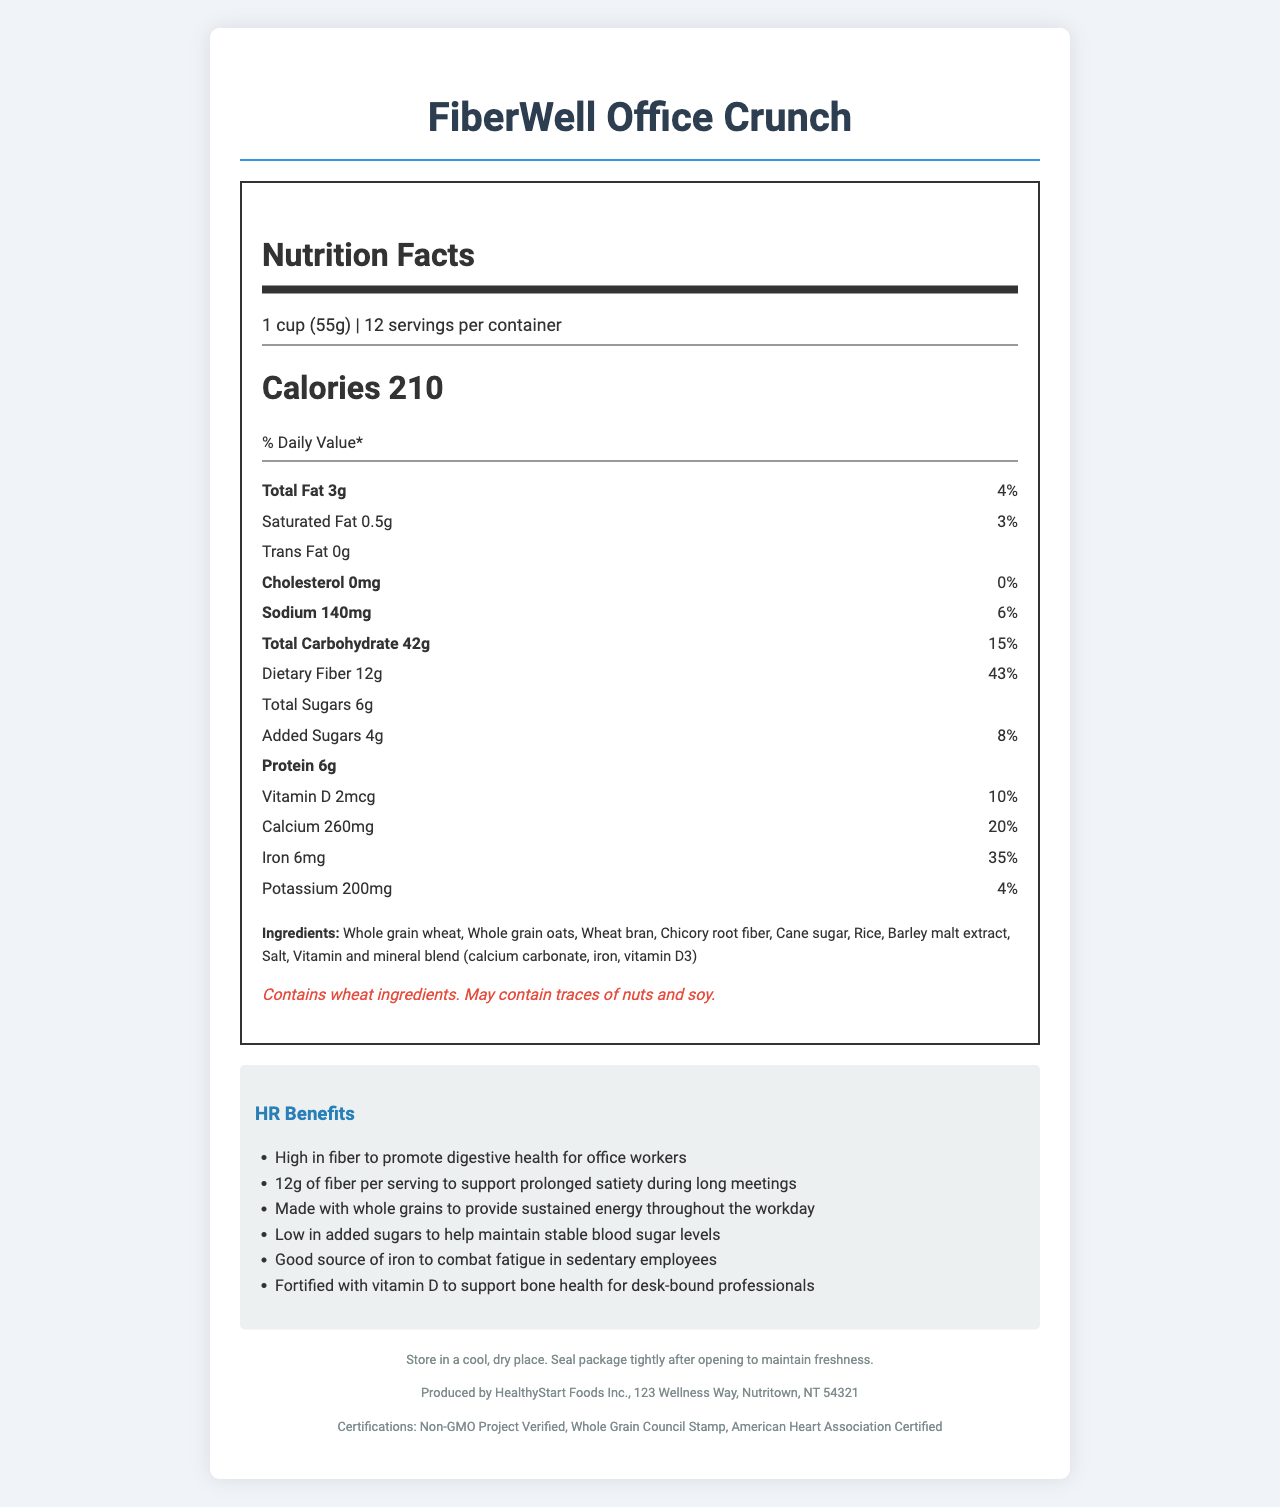what is the serving size of FiberWell Office Crunch? The serving size is provided in the document as "1 cup (55g)".
Answer: 1 cup (55g) how many servings are contained in one package? The document specifies that there are 12 servings per container.
Answer: 12 servings how many calories are in one serving of FiberWell Office Crunch? The calories per serving are labeled as 210.
Answer: 210 calories what is the percentage daily value of dietary fiber per serving? The daily value percentage of dietary fiber is indicated as 43%.
Answer: 43% which ingredient helps promote digestive health in office workers? Chicory root fiber is known for promoting digestive health and is listed as one of the ingredients.
Answer: Chicory root fiber what are the main sources of carbohydrates in FiberWell Office Crunch? A. Whole grain wheat and oats B. Cane sugar C. Chicory root fiber D. All of the above The main sources of carbohydrates are whole grain wheat and oats, as listed in the ingredient section.
Answer: A which nutrient is most likely targeted for combating fatigue among sedentary employees? A. Calcium B. Vitamin D C. Iron D. Sodium The claims for HR include "Good source of iron to combat fatigue in sedentary employees," making iron the correct answer.
Answer: C does FiberWell Office Crunch contain any trans fat? The document specifies that there are 0g of trans fat in the product.
Answer: No is FiberWell Office Crunch certified by the American Heart Association? The list of certifications includes "American Heart Association Certified."
Answer: Yes summarize the main health benefits promoted by FiberWell Office Crunch for office workers. The main health benefits include promoting digestive health with its high fiber content, providing sustained energy from whole grains, maintaining stable blood sugar due to its low added sugars, combating fatigue with a good source of iron, and supporting bone health with added vitamin D.
Answer: High in fiber for digestive health and prolonged satiety, provides sustained energy with whole grains, low in added sugars for stable blood sugar, good source of iron to combat fatigue, and fortified with vitamin D for bone health. how does the product help maintain stable blood sugar levels? The document mentions that the product is low in added sugars, which helps maintain stable blood sugar levels.
Answer: Low in added sugars what is the combined daily value percentage of vitamin D and calcium in one serving? Vitamin D has a daily value percentage of 10% and calcium has 20%, making a combined total of 30%.
Answer: 30% (10% for vitamin D + 20% for calcium) does the product contain potassium? FiberWell Office Crunch contains 200mg of potassium, which is 4% of the daily value.
Answer: Yes what is the storage instruction for maintaining the freshness of FiberWell Office Crunch? The storage instructions given in the document specify to store it in a cool, dry place and to seal the package tightly after opening.
Answer: Store in a cool, dry place. Seal package tightly after opening to maintain freshness. which organization produced FiberWell Office Crunch? The manufacturer information indicates that the product is produced by HealthyStart Foods Inc.
Answer: HealthyStart Foods Inc. what are the potential allergens found in FiberWell Office Crunch? The allergens listed include wheat and possible traces of nuts and soy.
Answer: Wheat, traces of nuts, and soy what is the exact location of HealthyStart Foods Inc.? The manufacturer info provides the location as "123 Wellness Way, Nutritown, NT 54321."
Answer: 123 Wellness Way, Nutritown, NT 54321 what certifications does FiberWell Office Crunch have? The document lists the certifications as Non-GMO Project Verified, Whole Grain Council Stamp, and American Heart Association Certified.
Answer: Non-GMO Project Verified, Whole Grain Council Stamp, American Heart Association Certified are there any allergens related to dairy in FiberWell Office Crunch? The document lists only wheat, nuts, and soy as allergens. There is no mention of dairy-related allergens.
Answer: Not enough information what percentage of the daily value of sodium does one serving contain? The daily value percentage of sodium per serving is listed as 6%.
Answer: 6% 